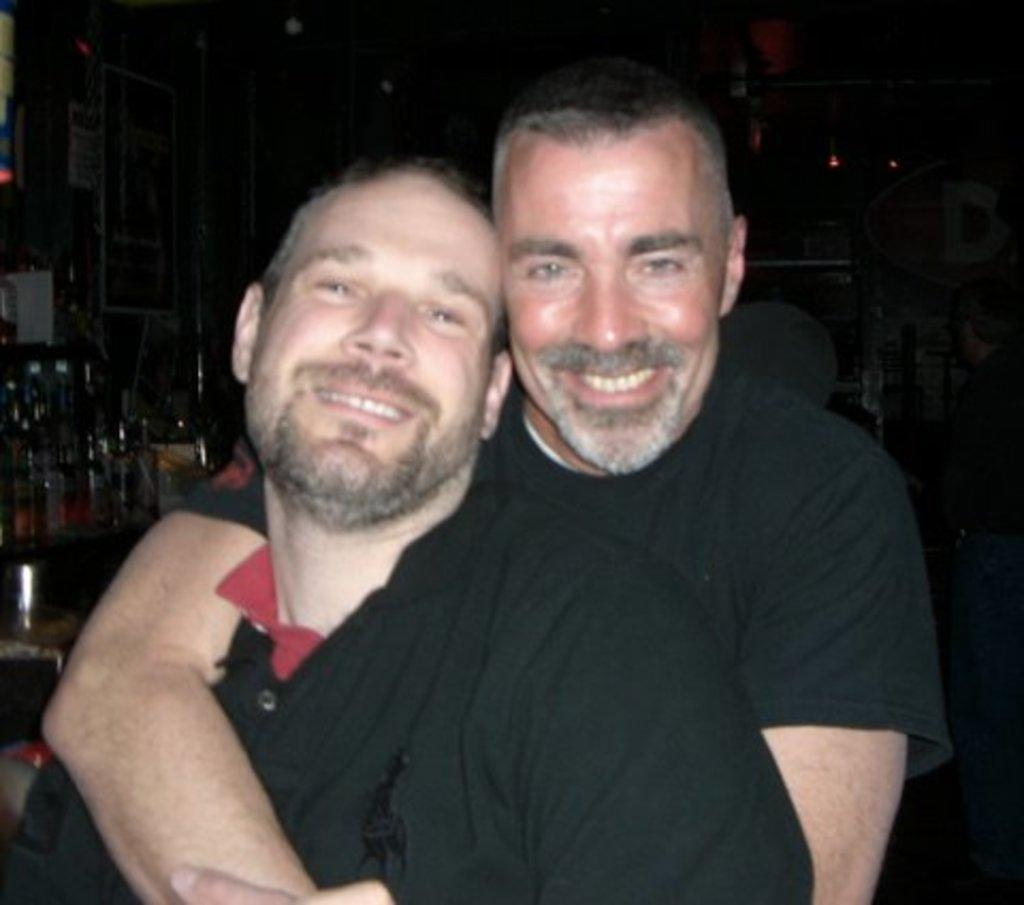How many people are in the image? There are two persons in the image. What are the persons wearing? The persons are wearing clothes. Where are the bottles located in the image? The bottles are on the left side of the image. What type of caption is written on the apples in the image? There are no apples present in the image, so there is no caption to be read. 